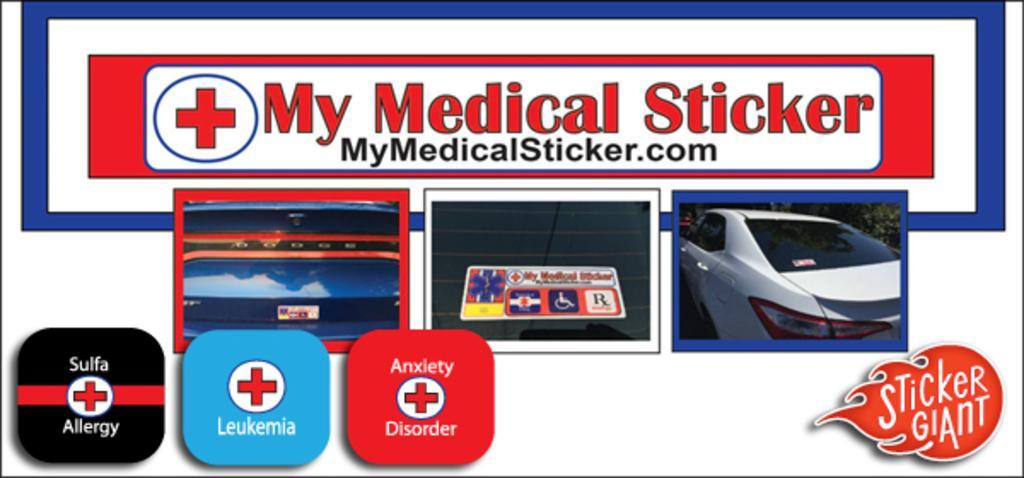Could you give a brief overview of what you see in this image? In this image I can see photos of a car and few other things. I can also see something is written at few places. 